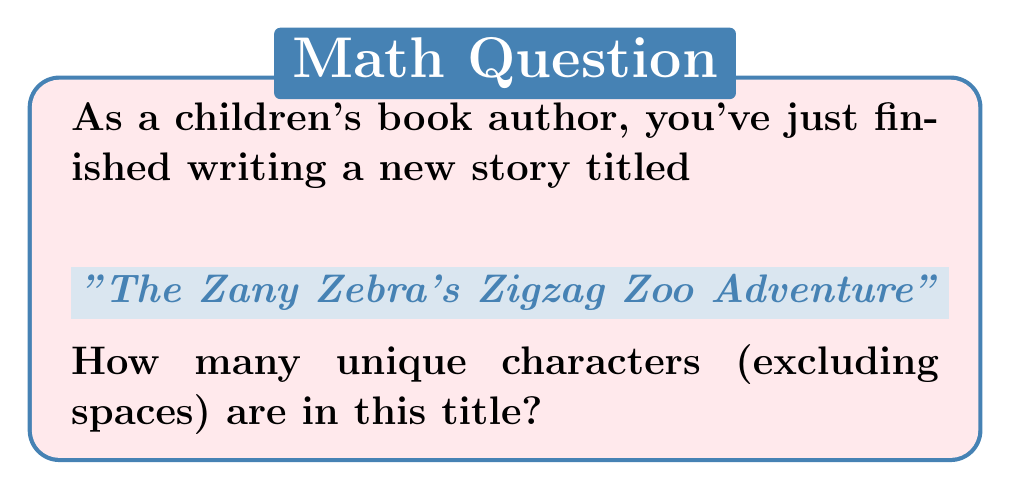Can you answer this question? Let's approach this step-by-step:

1) First, let's write out the title: "The Zany Zebra's Zigzag Zoo Adventure"

2) Now, let's identify each unique character:
   T, h, e, Z, a, n, y, b, r, ', s, i, g, o, A, d, v, t, u

3) To count:
   $$\text{Unique characters} = |\{T, h, e, Z, a, n, y, b, r, ', s, i, g, o, A, d, v, t, u\}|$$

4) Counting these unique characters:
   $$|\{T, h, e, Z, a, n, y, b, r, ', s, i, g, o, A, d, v, t, u\}| = 19$$

Note: We consider 'Z' and 'z' as different characters because they are case-sensitive. The apostrophe (') is also counted as a unique character.
Answer: 19 